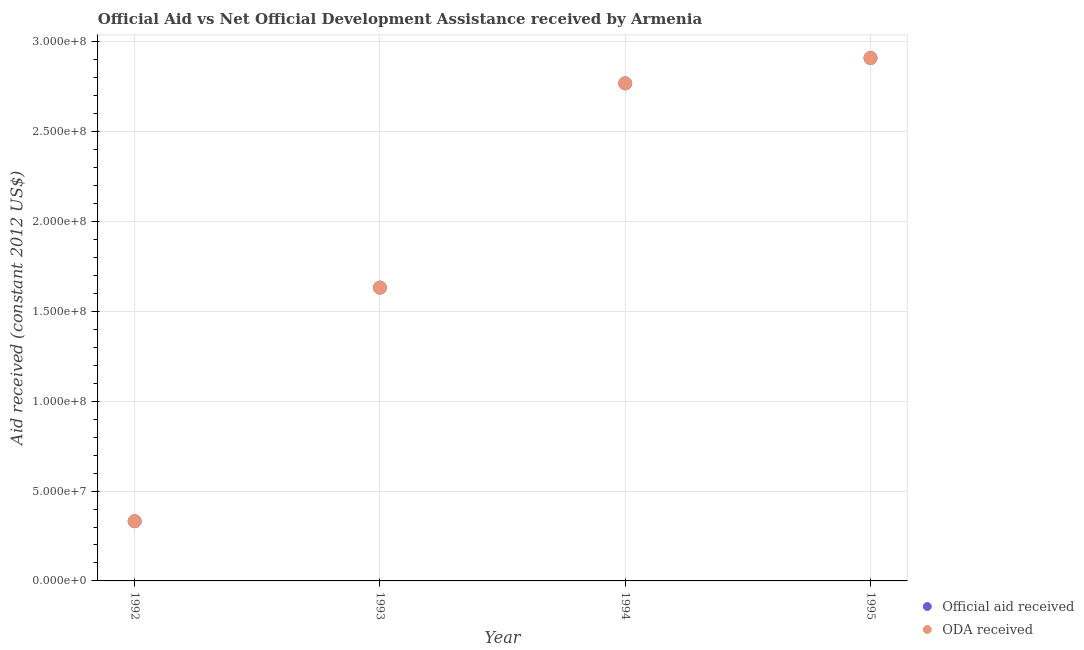Is the number of dotlines equal to the number of legend labels?
Provide a short and direct response. Yes. What is the oda received in 1993?
Ensure brevity in your answer.  1.63e+08. Across all years, what is the maximum official aid received?
Make the answer very short. 2.91e+08. Across all years, what is the minimum oda received?
Offer a very short reply. 3.32e+07. In which year was the official aid received minimum?
Offer a terse response. 1992. What is the total oda received in the graph?
Offer a very short reply. 7.64e+08. What is the difference between the oda received in 1993 and that in 1994?
Provide a succinct answer. -1.14e+08. What is the difference between the oda received in 1994 and the official aid received in 1992?
Your answer should be very brief. 2.44e+08. What is the average official aid received per year?
Ensure brevity in your answer.  1.91e+08. In the year 1992, what is the difference between the official aid received and oda received?
Offer a terse response. 0. In how many years, is the official aid received greater than 210000000 US$?
Your response must be concise. 2. What is the ratio of the official aid received in 1992 to that in 1995?
Provide a succinct answer. 0.11. What is the difference between the highest and the second highest official aid received?
Your answer should be compact. 1.41e+07. What is the difference between the highest and the lowest oda received?
Offer a very short reply. 2.58e+08. In how many years, is the official aid received greater than the average official aid received taken over all years?
Offer a terse response. 2. Is the oda received strictly less than the official aid received over the years?
Give a very brief answer. No. What is the difference between two consecutive major ticks on the Y-axis?
Provide a short and direct response. 5.00e+07. Are the values on the major ticks of Y-axis written in scientific E-notation?
Provide a succinct answer. Yes. Does the graph contain any zero values?
Your answer should be very brief. No. Where does the legend appear in the graph?
Provide a succinct answer. Bottom right. What is the title of the graph?
Provide a succinct answer. Official Aid vs Net Official Development Assistance received by Armenia . What is the label or title of the X-axis?
Your answer should be compact. Year. What is the label or title of the Y-axis?
Give a very brief answer. Aid received (constant 2012 US$). What is the Aid received (constant 2012 US$) of Official aid received in 1992?
Your response must be concise. 3.32e+07. What is the Aid received (constant 2012 US$) of ODA received in 1992?
Ensure brevity in your answer.  3.32e+07. What is the Aid received (constant 2012 US$) of Official aid received in 1993?
Your response must be concise. 1.63e+08. What is the Aid received (constant 2012 US$) in ODA received in 1993?
Your answer should be compact. 1.63e+08. What is the Aid received (constant 2012 US$) in Official aid received in 1994?
Offer a terse response. 2.77e+08. What is the Aid received (constant 2012 US$) in ODA received in 1994?
Your response must be concise. 2.77e+08. What is the Aid received (constant 2012 US$) of Official aid received in 1995?
Give a very brief answer. 2.91e+08. What is the Aid received (constant 2012 US$) in ODA received in 1995?
Make the answer very short. 2.91e+08. Across all years, what is the maximum Aid received (constant 2012 US$) of Official aid received?
Provide a succinct answer. 2.91e+08. Across all years, what is the maximum Aid received (constant 2012 US$) in ODA received?
Offer a terse response. 2.91e+08. Across all years, what is the minimum Aid received (constant 2012 US$) of Official aid received?
Ensure brevity in your answer.  3.32e+07. Across all years, what is the minimum Aid received (constant 2012 US$) of ODA received?
Make the answer very short. 3.32e+07. What is the total Aid received (constant 2012 US$) in Official aid received in the graph?
Keep it short and to the point. 7.64e+08. What is the total Aid received (constant 2012 US$) in ODA received in the graph?
Your response must be concise. 7.64e+08. What is the difference between the Aid received (constant 2012 US$) in Official aid received in 1992 and that in 1993?
Provide a short and direct response. -1.30e+08. What is the difference between the Aid received (constant 2012 US$) in ODA received in 1992 and that in 1993?
Your answer should be compact. -1.30e+08. What is the difference between the Aid received (constant 2012 US$) of Official aid received in 1992 and that in 1994?
Your answer should be very brief. -2.44e+08. What is the difference between the Aid received (constant 2012 US$) in ODA received in 1992 and that in 1994?
Ensure brevity in your answer.  -2.44e+08. What is the difference between the Aid received (constant 2012 US$) in Official aid received in 1992 and that in 1995?
Make the answer very short. -2.58e+08. What is the difference between the Aid received (constant 2012 US$) in ODA received in 1992 and that in 1995?
Offer a terse response. -2.58e+08. What is the difference between the Aid received (constant 2012 US$) in Official aid received in 1993 and that in 1994?
Your answer should be very brief. -1.14e+08. What is the difference between the Aid received (constant 2012 US$) of ODA received in 1993 and that in 1994?
Your answer should be compact. -1.14e+08. What is the difference between the Aid received (constant 2012 US$) in Official aid received in 1993 and that in 1995?
Provide a succinct answer. -1.28e+08. What is the difference between the Aid received (constant 2012 US$) in ODA received in 1993 and that in 1995?
Your response must be concise. -1.28e+08. What is the difference between the Aid received (constant 2012 US$) of Official aid received in 1994 and that in 1995?
Make the answer very short. -1.41e+07. What is the difference between the Aid received (constant 2012 US$) of ODA received in 1994 and that in 1995?
Offer a terse response. -1.41e+07. What is the difference between the Aid received (constant 2012 US$) of Official aid received in 1992 and the Aid received (constant 2012 US$) of ODA received in 1993?
Provide a succinct answer. -1.30e+08. What is the difference between the Aid received (constant 2012 US$) of Official aid received in 1992 and the Aid received (constant 2012 US$) of ODA received in 1994?
Offer a very short reply. -2.44e+08. What is the difference between the Aid received (constant 2012 US$) in Official aid received in 1992 and the Aid received (constant 2012 US$) in ODA received in 1995?
Your answer should be compact. -2.58e+08. What is the difference between the Aid received (constant 2012 US$) in Official aid received in 1993 and the Aid received (constant 2012 US$) in ODA received in 1994?
Make the answer very short. -1.14e+08. What is the difference between the Aid received (constant 2012 US$) of Official aid received in 1993 and the Aid received (constant 2012 US$) of ODA received in 1995?
Give a very brief answer. -1.28e+08. What is the difference between the Aid received (constant 2012 US$) of Official aid received in 1994 and the Aid received (constant 2012 US$) of ODA received in 1995?
Ensure brevity in your answer.  -1.41e+07. What is the average Aid received (constant 2012 US$) in Official aid received per year?
Ensure brevity in your answer.  1.91e+08. What is the average Aid received (constant 2012 US$) in ODA received per year?
Offer a very short reply. 1.91e+08. In the year 1992, what is the difference between the Aid received (constant 2012 US$) of Official aid received and Aid received (constant 2012 US$) of ODA received?
Offer a very short reply. 0. In the year 1993, what is the difference between the Aid received (constant 2012 US$) of Official aid received and Aid received (constant 2012 US$) of ODA received?
Provide a succinct answer. 0. In the year 1994, what is the difference between the Aid received (constant 2012 US$) of Official aid received and Aid received (constant 2012 US$) of ODA received?
Make the answer very short. 0. What is the ratio of the Aid received (constant 2012 US$) in Official aid received in 1992 to that in 1993?
Provide a short and direct response. 0.2. What is the ratio of the Aid received (constant 2012 US$) in ODA received in 1992 to that in 1993?
Your response must be concise. 0.2. What is the ratio of the Aid received (constant 2012 US$) in Official aid received in 1992 to that in 1994?
Offer a terse response. 0.12. What is the ratio of the Aid received (constant 2012 US$) in ODA received in 1992 to that in 1994?
Ensure brevity in your answer.  0.12. What is the ratio of the Aid received (constant 2012 US$) of Official aid received in 1992 to that in 1995?
Your response must be concise. 0.11. What is the ratio of the Aid received (constant 2012 US$) of ODA received in 1992 to that in 1995?
Offer a terse response. 0.11. What is the ratio of the Aid received (constant 2012 US$) of Official aid received in 1993 to that in 1994?
Your response must be concise. 0.59. What is the ratio of the Aid received (constant 2012 US$) of ODA received in 1993 to that in 1994?
Offer a terse response. 0.59. What is the ratio of the Aid received (constant 2012 US$) of Official aid received in 1993 to that in 1995?
Make the answer very short. 0.56. What is the ratio of the Aid received (constant 2012 US$) in ODA received in 1993 to that in 1995?
Offer a terse response. 0.56. What is the ratio of the Aid received (constant 2012 US$) in Official aid received in 1994 to that in 1995?
Provide a succinct answer. 0.95. What is the ratio of the Aid received (constant 2012 US$) in ODA received in 1994 to that in 1995?
Your answer should be very brief. 0.95. What is the difference between the highest and the second highest Aid received (constant 2012 US$) in Official aid received?
Your answer should be very brief. 1.41e+07. What is the difference between the highest and the second highest Aid received (constant 2012 US$) of ODA received?
Offer a terse response. 1.41e+07. What is the difference between the highest and the lowest Aid received (constant 2012 US$) in Official aid received?
Provide a short and direct response. 2.58e+08. What is the difference between the highest and the lowest Aid received (constant 2012 US$) of ODA received?
Ensure brevity in your answer.  2.58e+08. 